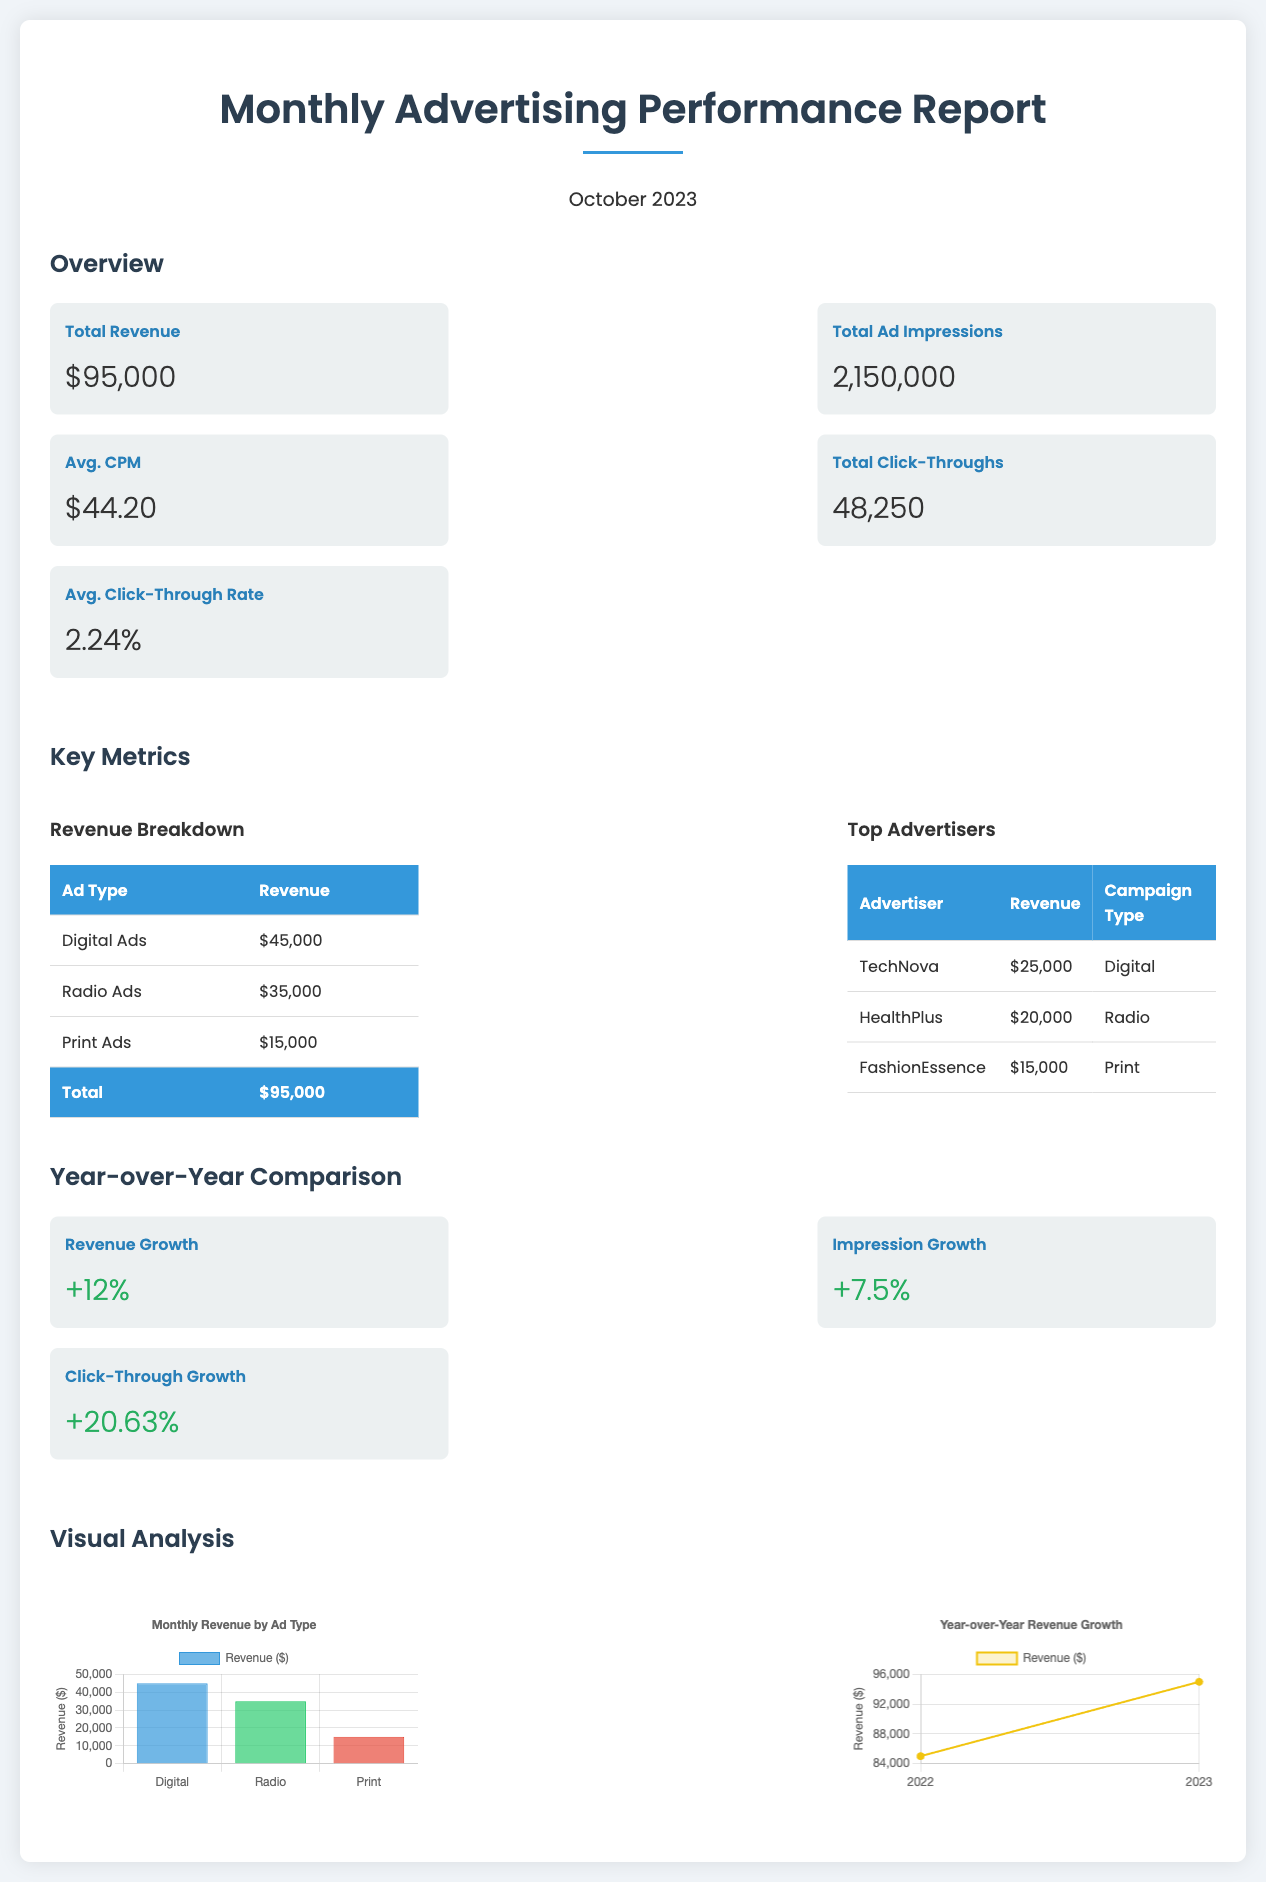what is the total revenue? The total revenue is shown in the overview section as $95,000.
Answer: $95,000 what is the average click-through rate? The average click-through rate is provided in the overview section as 2.24%.
Answer: 2.24% how many total ad impressions were recorded? The total ad impressions are stated in the overview section as 2,150,000.
Answer: 2,150,000 which ad type earned the most revenue? The revenue breakdown indicates that Digital Ads earned $45,000, more than the others.
Answer: Digital Ads what is the revenue growth percentage compared to last year? The year-over-year comparison shows a revenue growth of +12%.
Answer: +12% how many total click-throughs were there? The document indicates the total click-throughs in the overview as 48,250.
Answer: 48,250 who is the top advertiser by revenue? In the top advertisers section, TechNova is listed with the highest revenue of $25,000.
Answer: TechNova what is the percentage increase in click-throughs? The document states that click-through growth is +20.63% in the year-over-year comparison.
Answer: +20.63% which chart displays monthly revenue by ad type? The chart titled "Monthly Revenue by Ad Type" illustrates revenue distribution across different ad types.
Answer: Monthly Revenue by Ad Type 